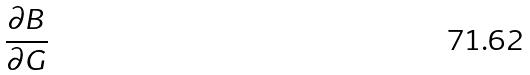Convert formula to latex. <formula><loc_0><loc_0><loc_500><loc_500>\frac { \partial B } { \partial G }</formula> 